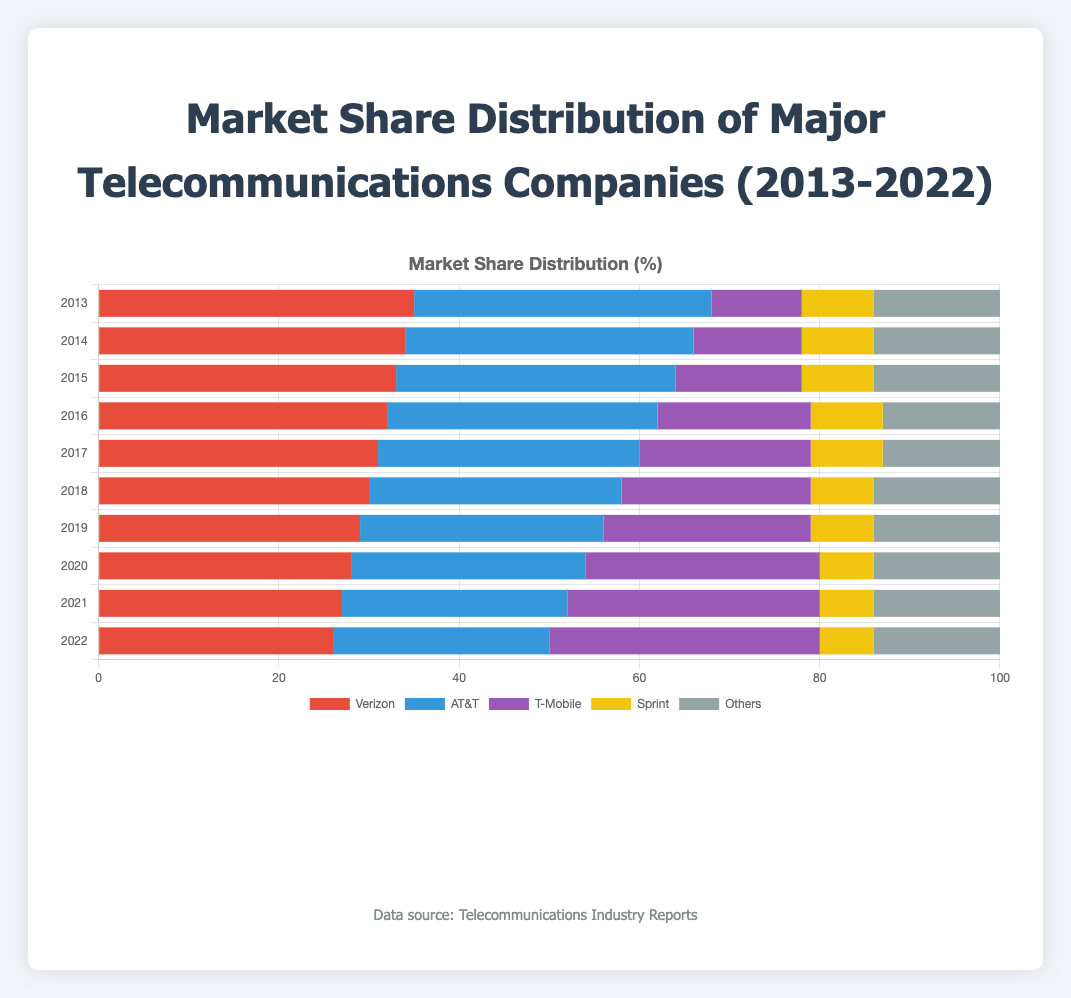What was the market share of T-Mobile in 2016 and 2022 combined? T-Mobile had a 17% market share in 2016 and a 30% market share in 2022. Summing these, 17 + 30 = 47.
Answer: 47% Which company had the highest market share in 2022? In 2022, T-Mobile had the highest market share at 30%.
Answer: T-Mobile Did Sprint's market share change between 2013 and 2022? Sprint had an 8% market share in 2013 and a 6% market share in 2022. The change is 8 - 6 = 2.
Answer: Yes, it decreased by 2% Compare the market share trends of Verizon and T-Mobile. Which company had a consistent increase or decrease over the years? Verizon's market share decreased steadily from 35% in 2013 to 26% in 2022. T-Mobile's market share consistently increased from 10% in 2013 to 30% in 2022.
Answer: Verizon decreased, T-Mobile increased What is the color of the bars representing AT&T? The bars representing AT&T are colored blue.
Answer: Blue During which year did T-Mobile's market share surpass that of AT&T? T-Mobile's market share surpassed AT&T in 2020 when it had 26%, compared to AT&T's 26%, which was equal but surpassed in the following year 2021.
Answer: 2021 Calculate the average market share of Verizon over the decade. Verizon's market shares from 2013 to 2022 are: 35, 34, 33, 32, 31, 30, 29, 28, 27, 26. Summing these: 35 + 34 + 33 + 32 + 31 + 30 + 29 + 28 + 27 + 26 = 305. The average over 10 years is 305/10 = 30.5.
Answer: 30.5% How did the "Others" category market share change from 2013 to 2022? The "Others" category had a market share of 14% in 2013 and also 14% in 2022, indicating no change.
Answer: No change Which year did Verizon have the lowest market share? Verizon had the lowest market share in 2022 at 26%.
Answer: 2022 